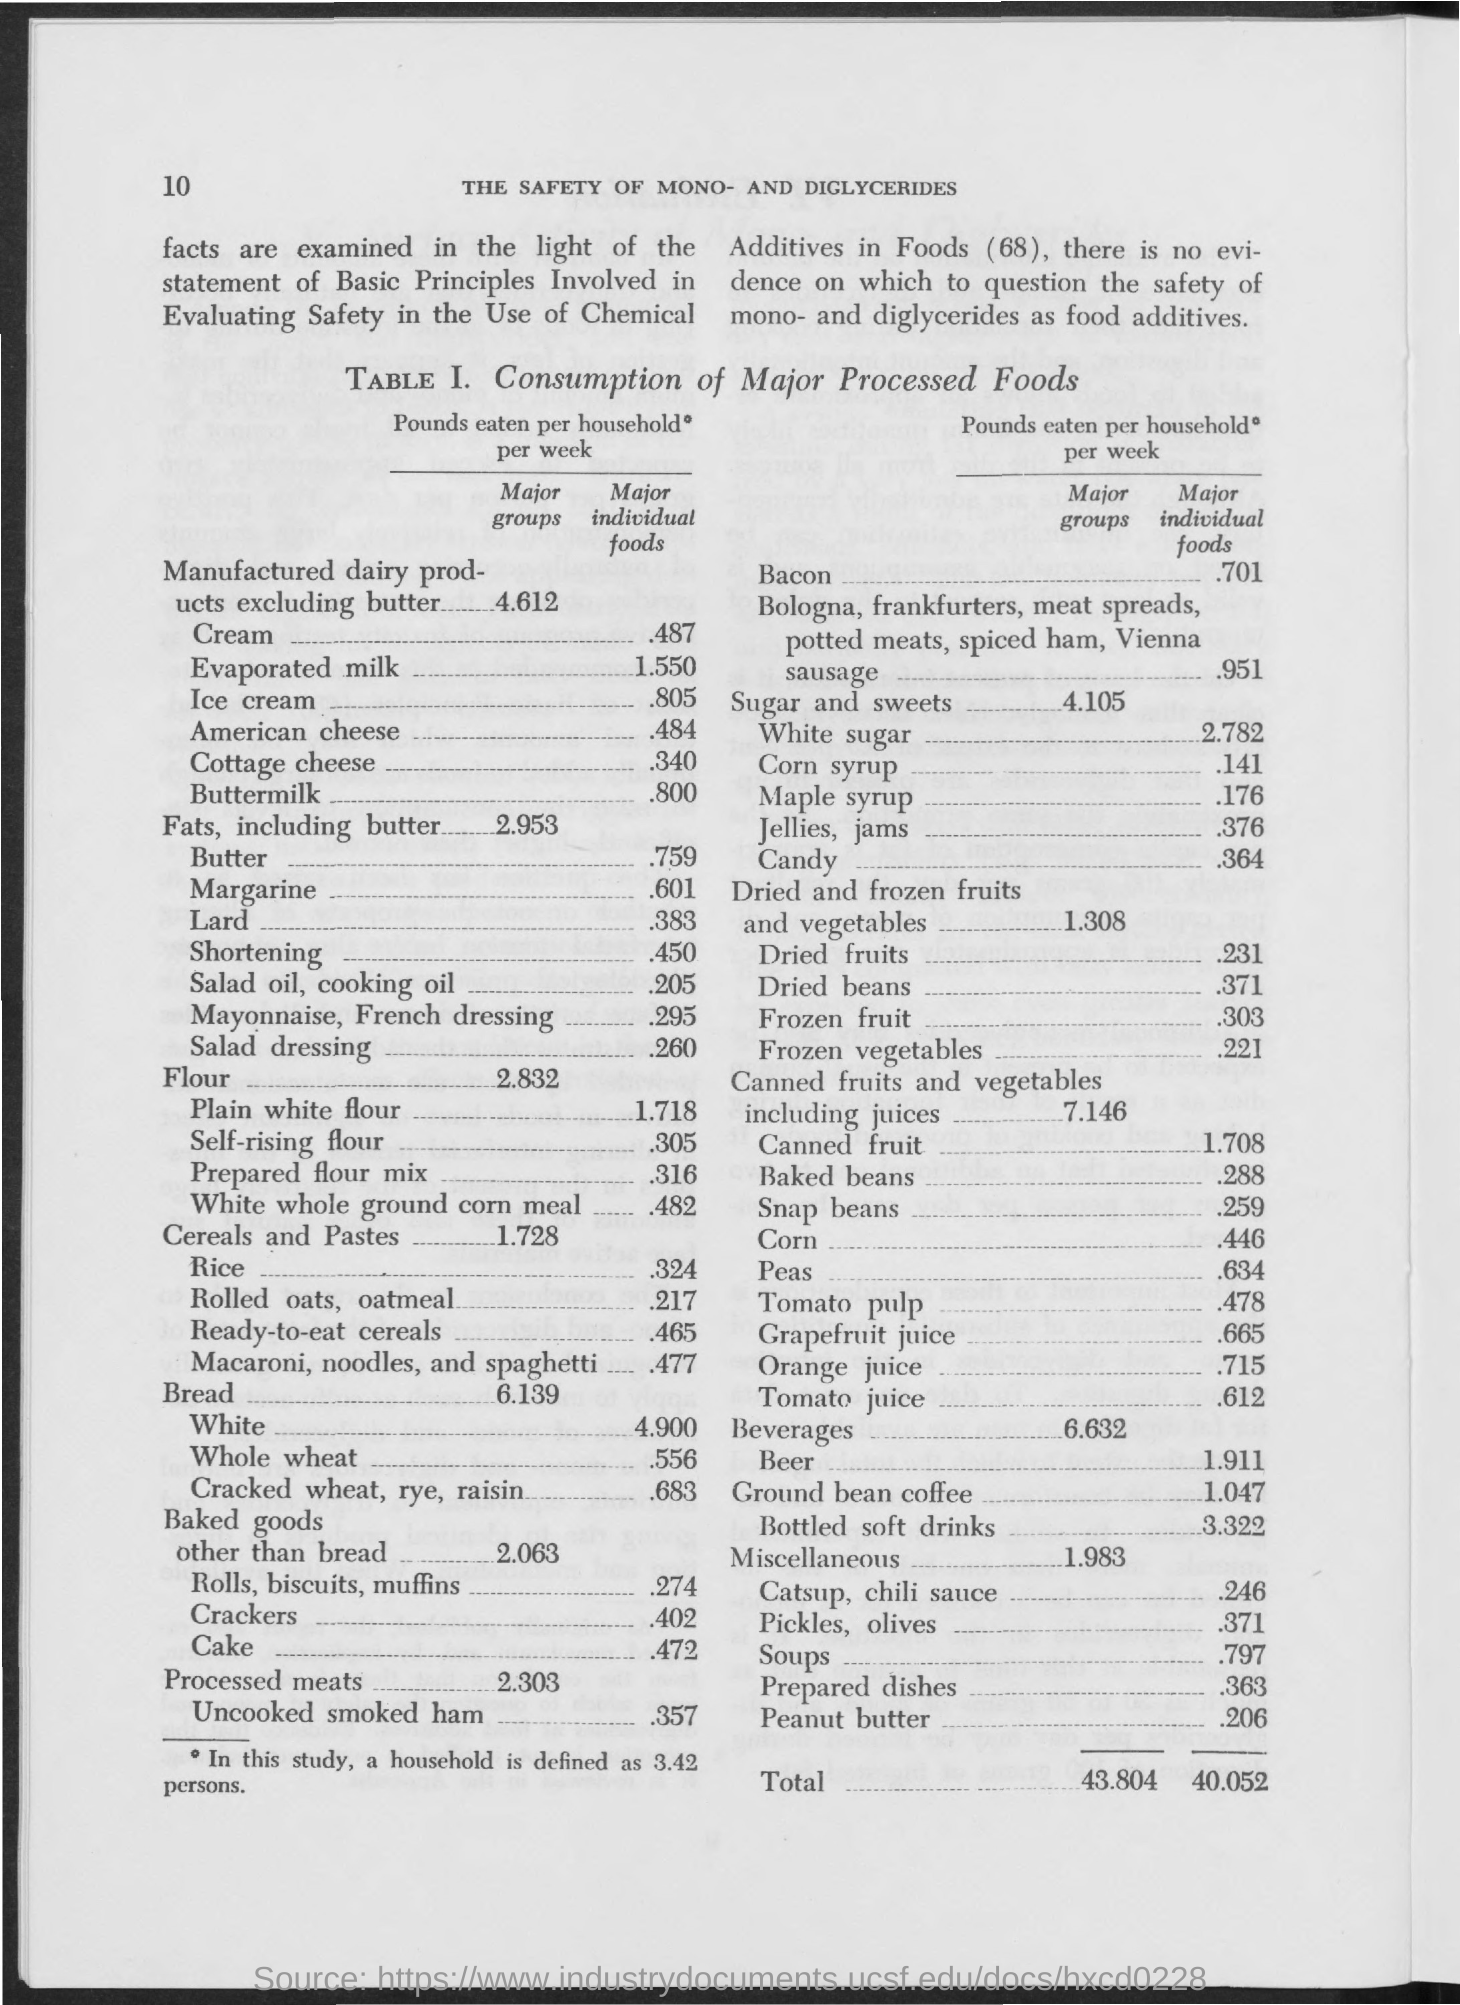Identify some key points in this picture. The title of Table 1 is "Consumption of Major Processed Foods and Associated Risk of Cancer in Mexico", which provides an overview of the consumption patterns of major processed foods in Mexico and the potential link to cancer risk. In this study, a household was defined as having 3.42 persons. 